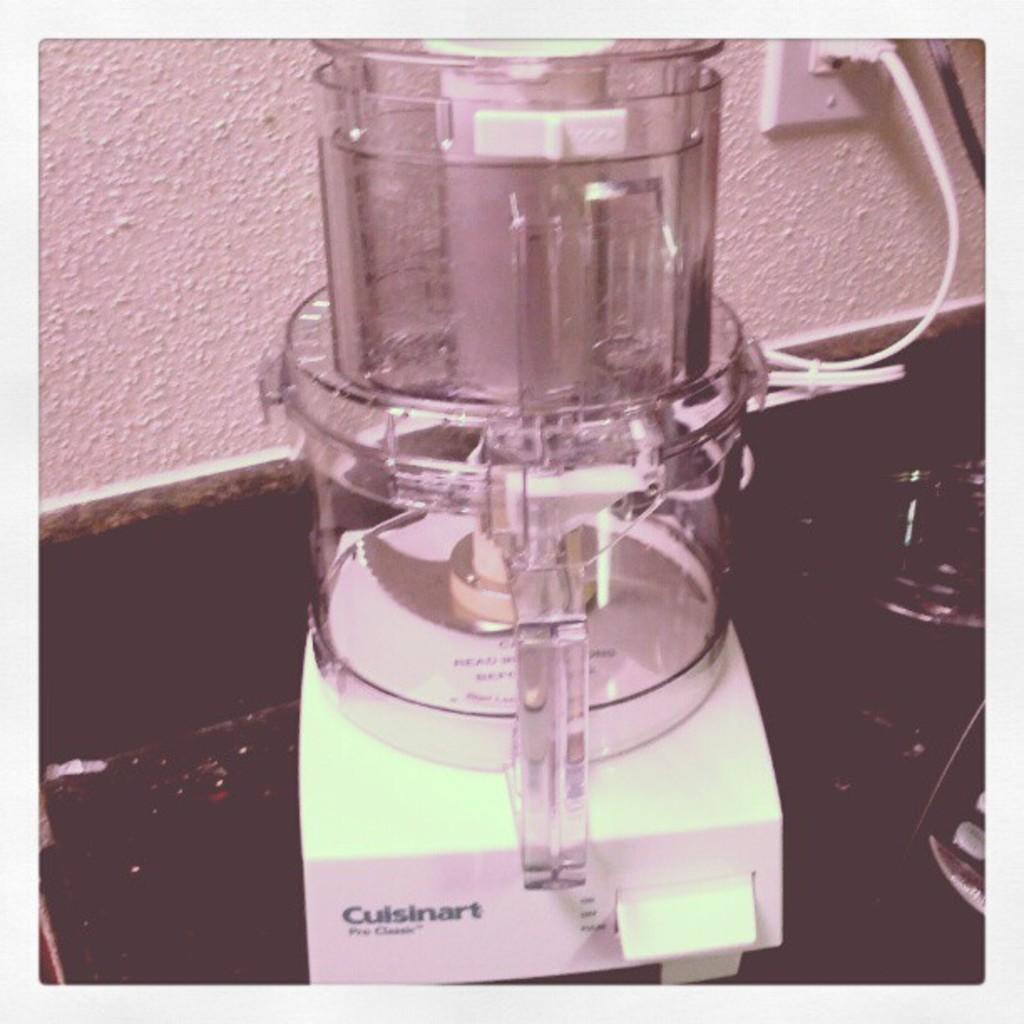Who makes this food processor?
Keep it short and to the point. Cuisinart. 